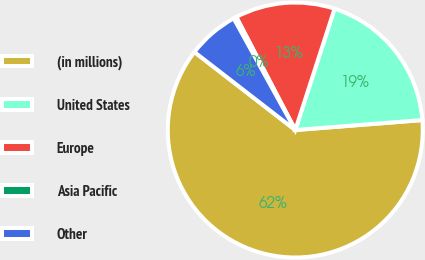<chart> <loc_0><loc_0><loc_500><loc_500><pie_chart><fcel>(in millions)<fcel>United States<fcel>Europe<fcel>Asia Pacific<fcel>Other<nl><fcel>61.72%<fcel>18.77%<fcel>12.64%<fcel>0.37%<fcel>6.5%<nl></chart> 